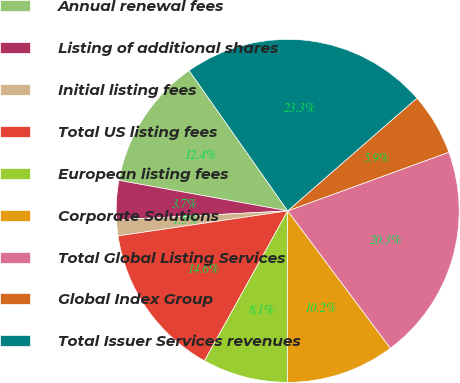Convert chart to OTSL. <chart><loc_0><loc_0><loc_500><loc_500><pie_chart><fcel>Annual renewal fees<fcel>Listing of additional shares<fcel>Initial listing fees<fcel>Total US listing fees<fcel>European listing fees<fcel>Corporate Solutions<fcel>Total Global Listing Services<fcel>Global Index Group<fcel>Total Issuer Services revenues<nl><fcel>12.41%<fcel>3.68%<fcel>1.5%<fcel>14.6%<fcel>8.05%<fcel>10.23%<fcel>20.34%<fcel>5.86%<fcel>23.33%<nl></chart> 